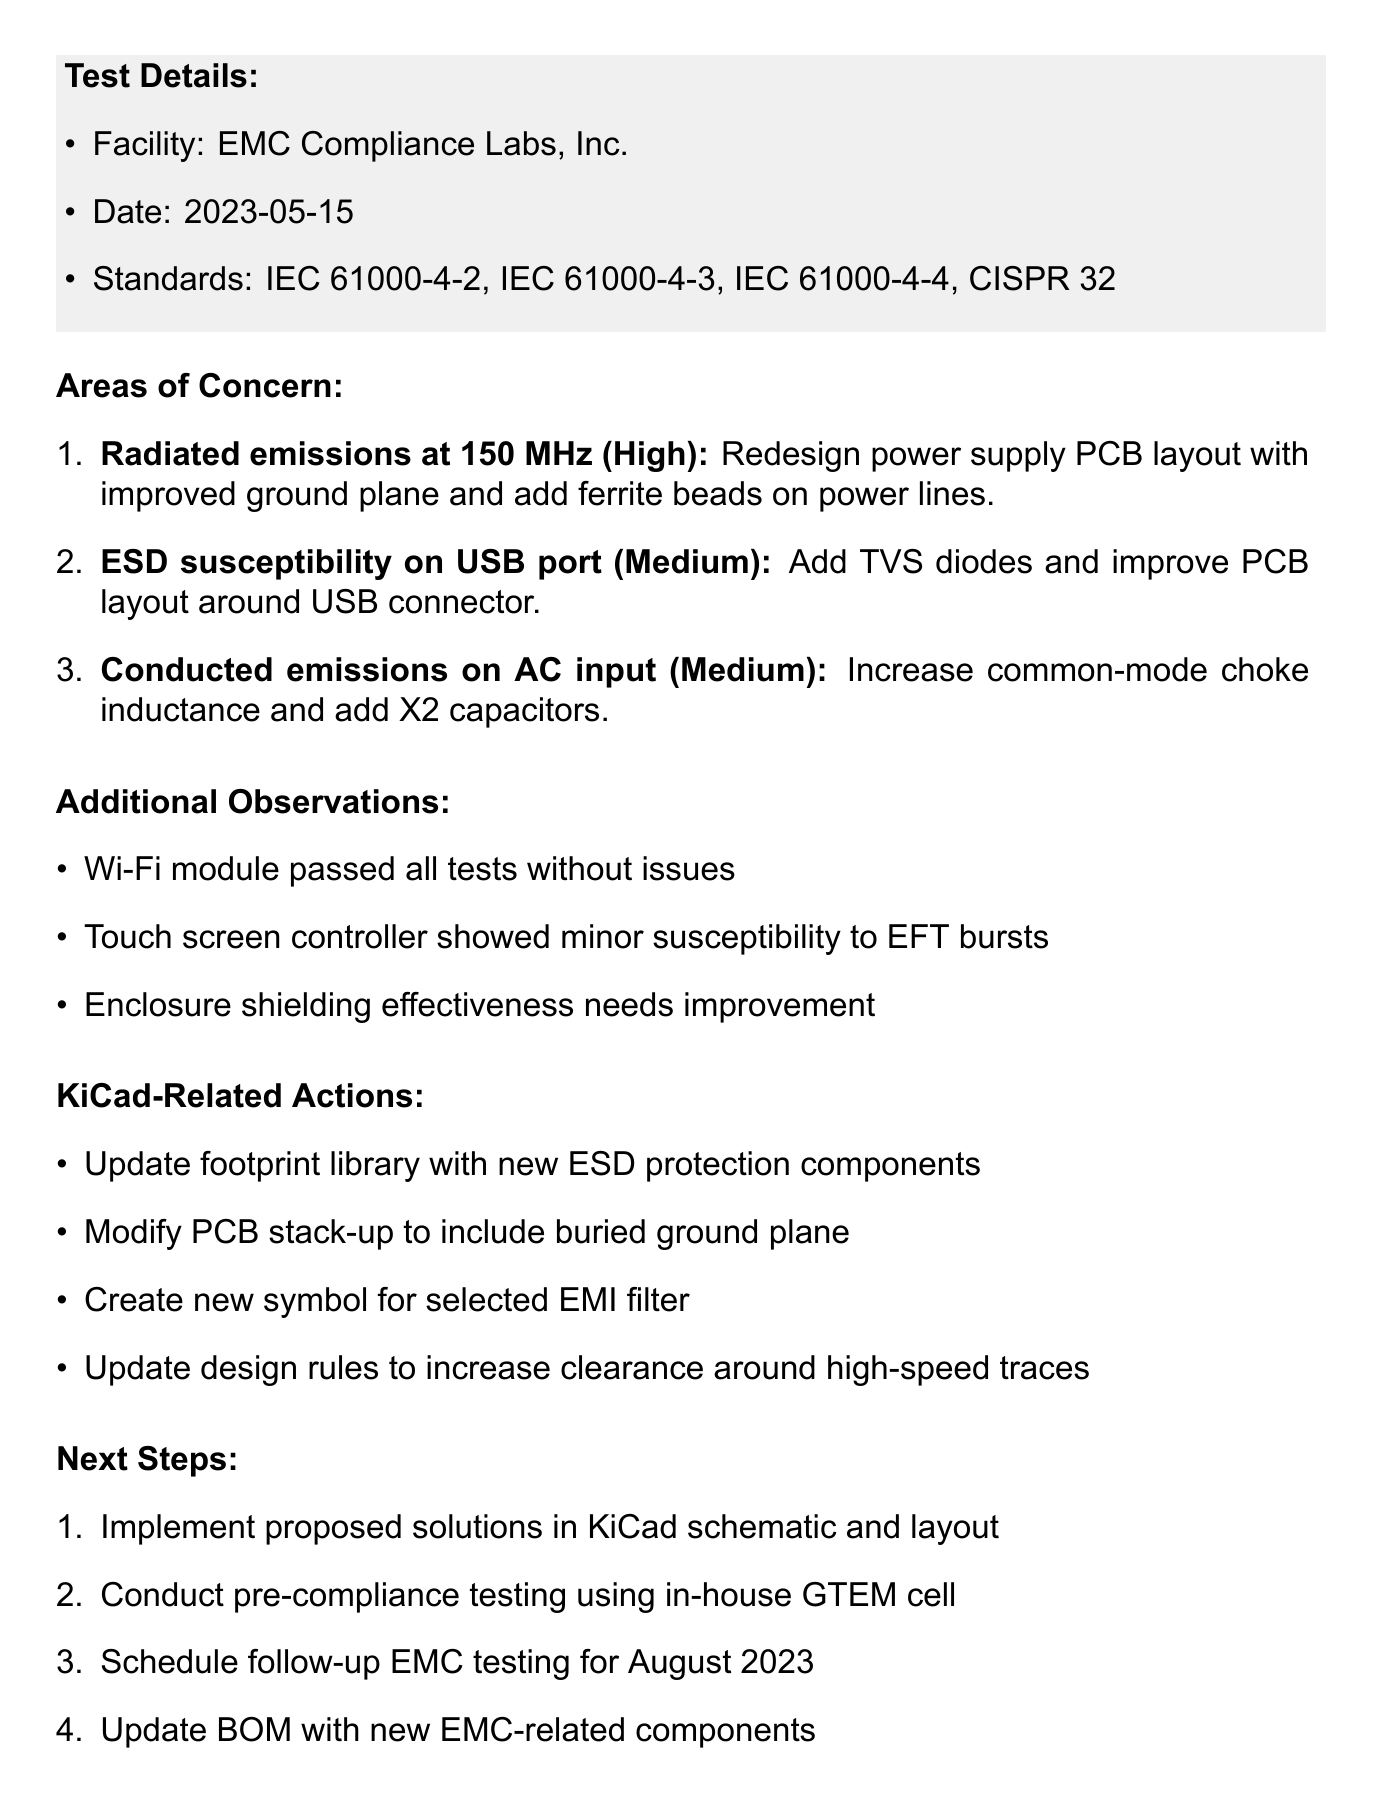what is the product name tested? The product name is clearly stated at the beginning of the memo.
Answer: XR-5000 Smart Home Controller what is the testing date? The date of the testing is mentioned under the test details section.
Answer: 2023-05-15 which standard shows high severity concern? The severity levels of concerns are listed in the areas of concern section.
Answer: Radiated emissions exceeding limits at 150 MHz who is the project lead? The team responsibilities section lists the roles and names of team members.
Answer: Sarah Johnson what is one proposed solution for ESD susceptibility on USB port? Each area of concern includes a proposed solution to address the issue.
Answer: Add TVS diodes and improve PCB layout around USB connector how many areas of concern are listed? The number of areas of concern can be counted in the corresponding section.
Answer: Three which component showed minor susceptibility to EFT bursts? The additional observations section provides insights into component behavior during testing.
Answer: Touch screen controller what will be scheduled for August 2023? The next steps outline future actions and testing schedules.
Answer: Follow-up EMC testing 